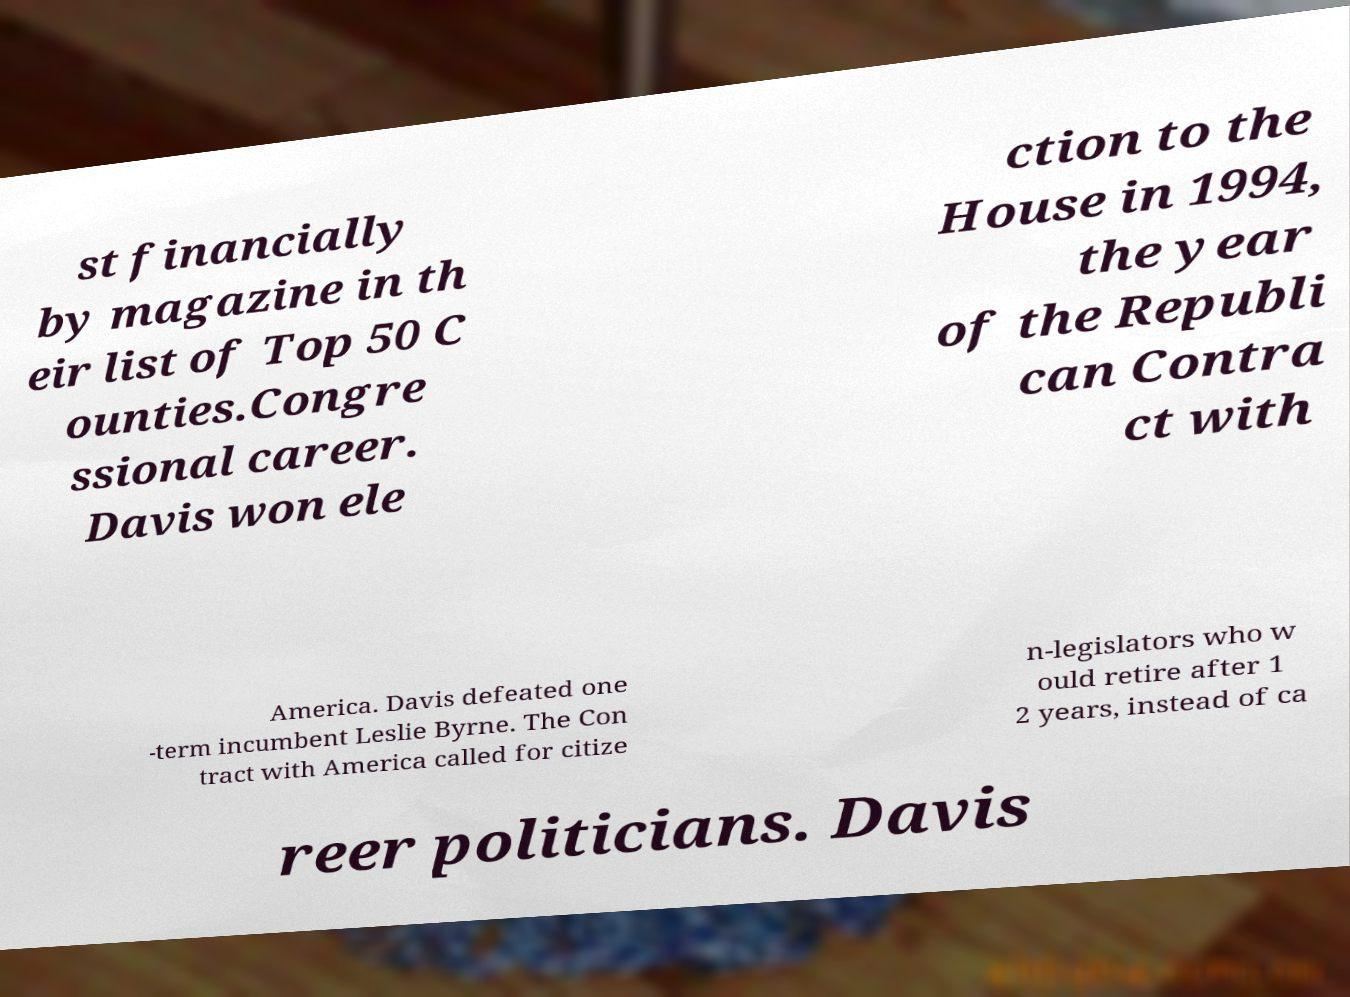For documentation purposes, I need the text within this image transcribed. Could you provide that? st financially by magazine in th eir list of Top 50 C ounties.Congre ssional career. Davis won ele ction to the House in 1994, the year of the Republi can Contra ct with America. Davis defeated one -term incumbent Leslie Byrne. The Con tract with America called for citize n-legislators who w ould retire after 1 2 years, instead of ca reer politicians. Davis 